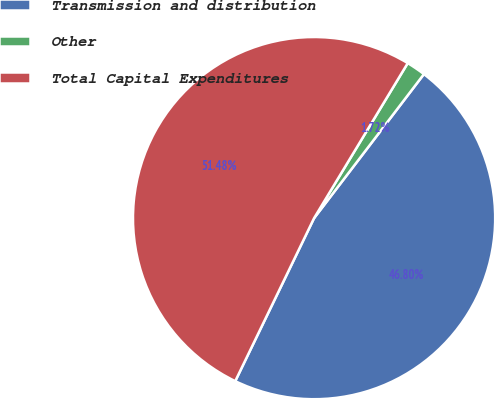Convert chart. <chart><loc_0><loc_0><loc_500><loc_500><pie_chart><fcel>Transmission and distribution<fcel>Other<fcel>Total Capital Expenditures<nl><fcel>46.8%<fcel>1.72%<fcel>51.48%<nl></chart> 